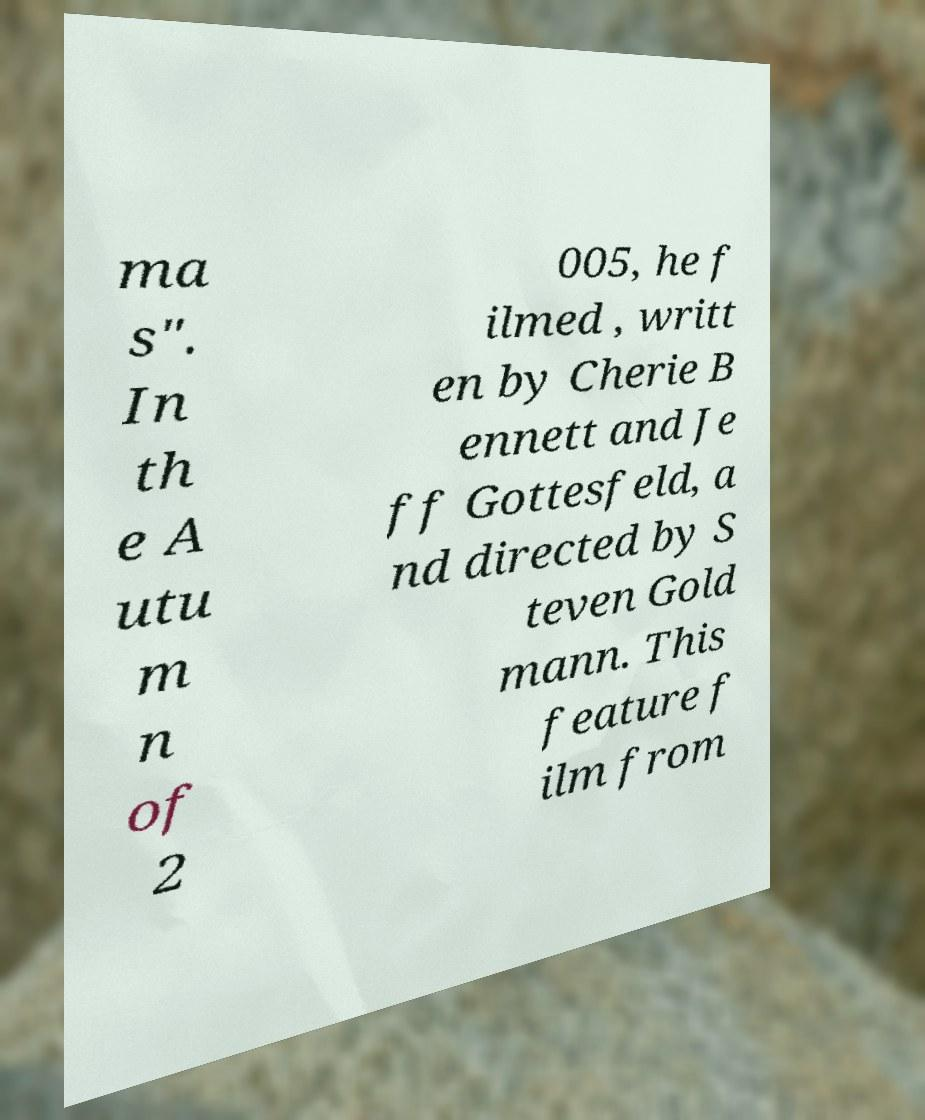Please identify and transcribe the text found in this image. ma s". In th e A utu m n of 2 005, he f ilmed , writt en by Cherie B ennett and Je ff Gottesfeld, a nd directed by S teven Gold mann. This feature f ilm from 